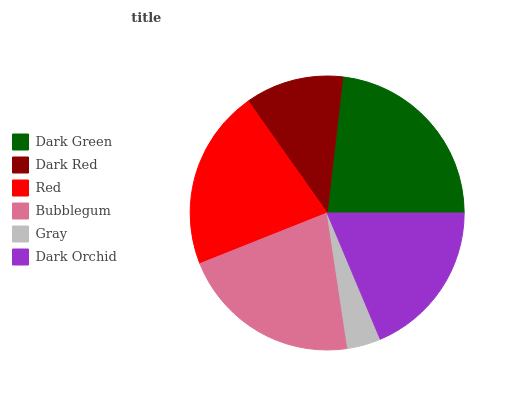Is Gray the minimum?
Answer yes or no. Yes. Is Dark Green the maximum?
Answer yes or no. Yes. Is Dark Red the minimum?
Answer yes or no. No. Is Dark Red the maximum?
Answer yes or no. No. Is Dark Green greater than Dark Red?
Answer yes or no. Yes. Is Dark Red less than Dark Green?
Answer yes or no. Yes. Is Dark Red greater than Dark Green?
Answer yes or no. No. Is Dark Green less than Dark Red?
Answer yes or no. No. Is Red the high median?
Answer yes or no. Yes. Is Dark Orchid the low median?
Answer yes or no. Yes. Is Dark Red the high median?
Answer yes or no. No. Is Dark Red the low median?
Answer yes or no. No. 